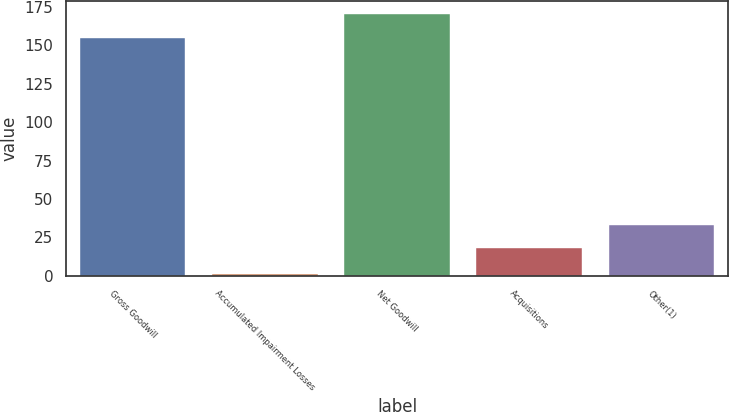<chart> <loc_0><loc_0><loc_500><loc_500><bar_chart><fcel>Gross Goodwill<fcel>Accumulated Impairment Losses<fcel>Net Goodwill<fcel>Acquisitions<fcel>Other(1)<nl><fcel>155<fcel>1.09<fcel>170.39<fcel>18<fcel>33.39<nl></chart> 